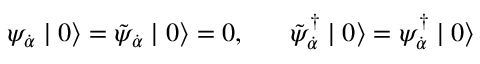<formula> <loc_0><loc_0><loc_500><loc_500>\psi _ { \dot { \alpha } } | 0 \rangle = \tilde { \psi } _ { \dot { \alpha } } | 0 \rangle = 0 , \, \tilde { \psi } _ { \dot { \alpha } } ^ { \dagger } | 0 \rangle = \psi _ { \dot { \alpha } } ^ { \dagger } | 0 \rangle</formula> 